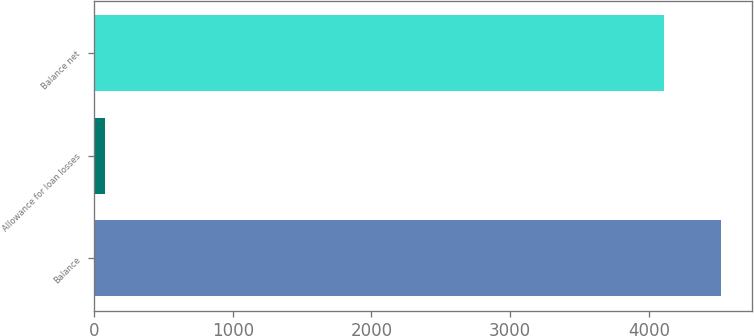<chart> <loc_0><loc_0><loc_500><loc_500><bar_chart><fcel>Balance<fcel>Allowance for loan losses<fcel>Balance net<nl><fcel>4518.8<fcel>77<fcel>4108<nl></chart> 